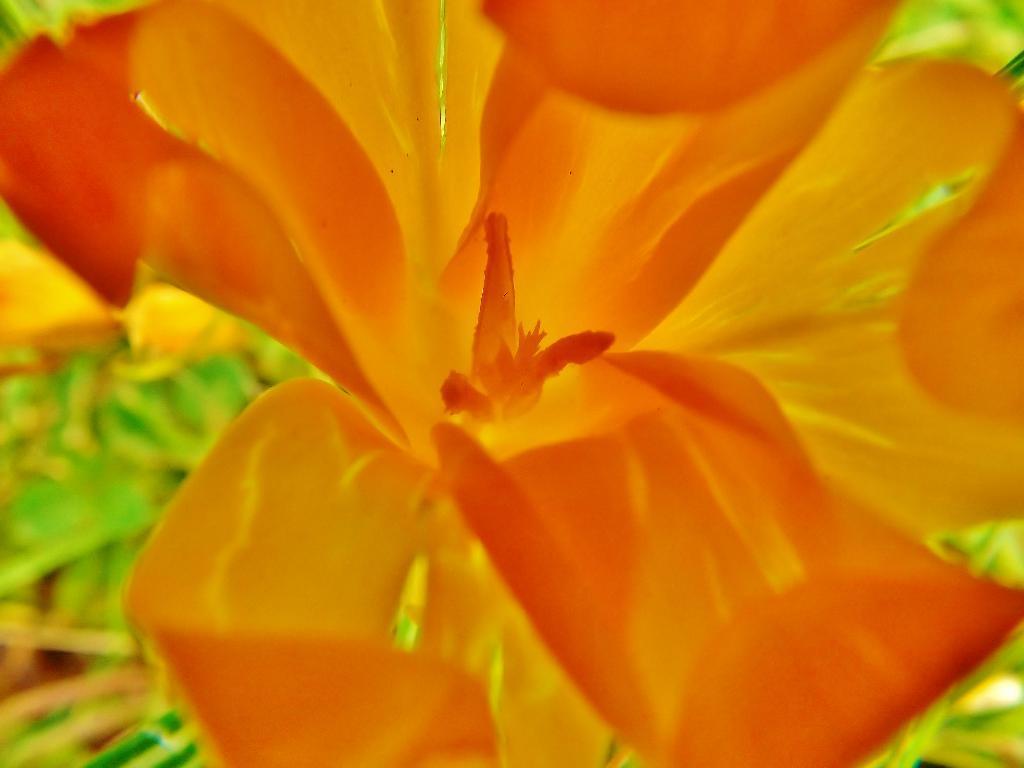Could you give a brief overview of what you see in this image? In the picture I can see an orange color flower. The background of the image is blurred. 